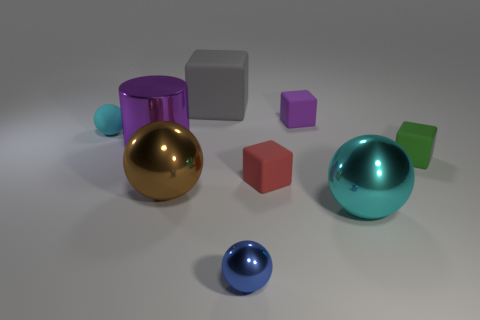Which object in the image is the largest? The largest object appears to be the green sphere on the right side of the image. Its size is greater than the other objects in the set. 